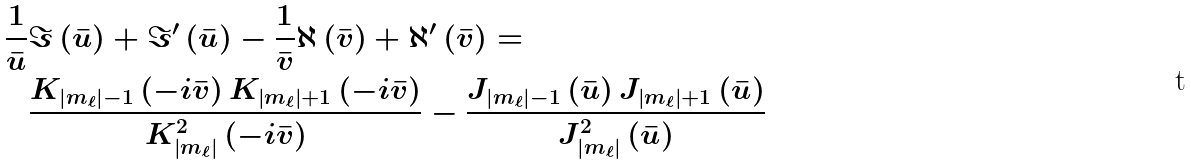<formula> <loc_0><loc_0><loc_500><loc_500>\frac { 1 } { \bar { u } } & \Im \left ( \bar { u } \right ) + \Im ^ { \prime } \left ( \bar { u } \right ) - \frac { 1 } { \bar { v } } \aleph \left ( \bar { v } \right ) + \aleph ^ { \prime } \left ( \bar { v } \right ) = \\ & \frac { K _ { \left | m _ { \ell } \right | - 1 } \left ( - i \bar { v } \right ) K _ { \left | m _ { \ell } \right | + 1 } \left ( - i \bar { v } \right ) } { K _ { \left | m _ { \ell } \right | } ^ { 2 } \left ( - i \bar { v } \right ) } - \frac { J _ { \left | m _ { \ell } \right | - 1 } \left ( \bar { u } \right ) J _ { \left | m _ { \ell } \right | + 1 } \left ( \bar { u } \right ) } { J _ { \left | m _ { \ell } \right | } ^ { 2 } \left ( \bar { u } \right ) }</formula> 